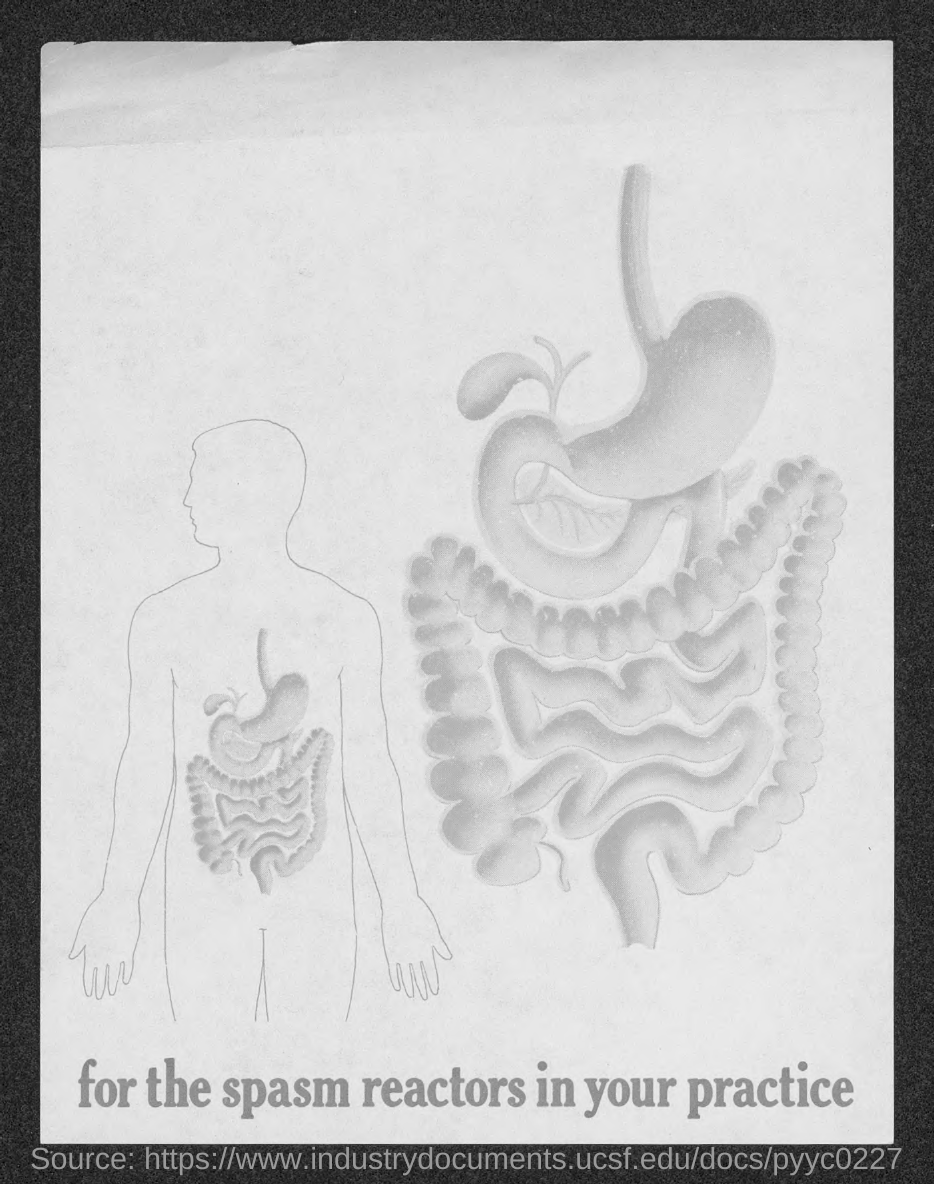What is the text given in this document?
Make the answer very short. For the spasm reactors in your practice. 